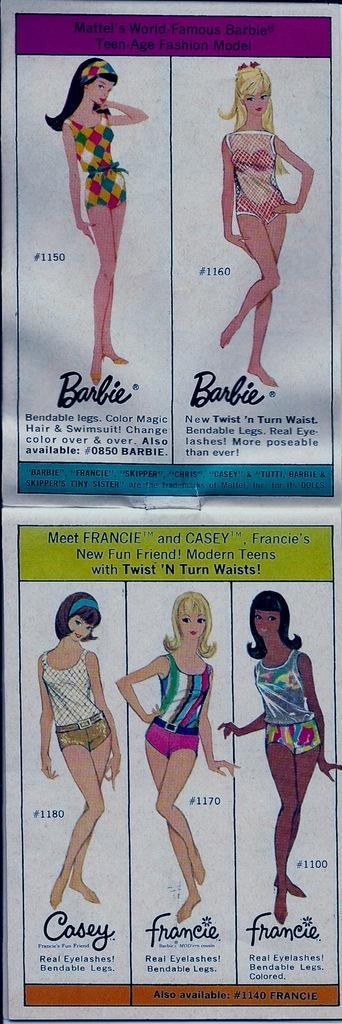Describe this image in one or two sentences. In this picture there is a image of few women wearing different color dresses and there is something written above and below the image. 